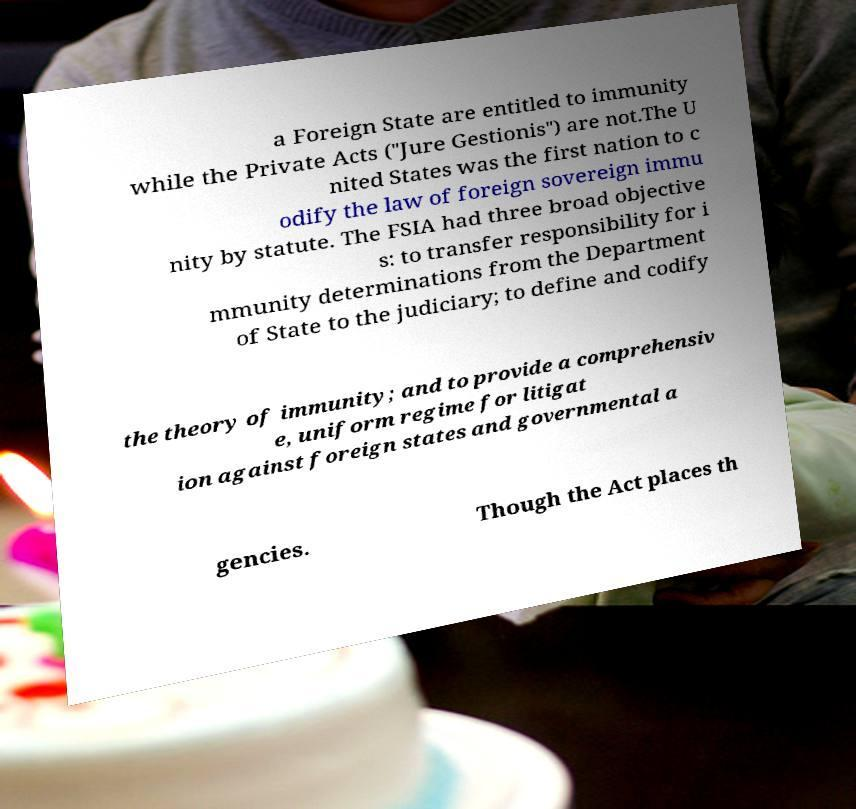Can you accurately transcribe the text from the provided image for me? a Foreign State are entitled to immunity while the Private Acts ("Jure Gestionis") are not.The U nited States was the first nation to c odify the law of foreign sovereign immu nity by statute. The FSIA had three broad objective s: to transfer responsibility for i mmunity determinations from the Department of State to the judiciary; to define and codify the theory of immunity; and to provide a comprehensiv e, uniform regime for litigat ion against foreign states and governmental a gencies. Though the Act places th 